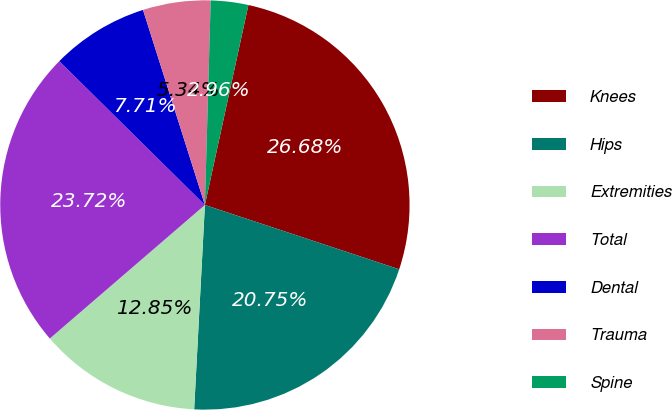<chart> <loc_0><loc_0><loc_500><loc_500><pie_chart><fcel>Knees<fcel>Hips<fcel>Extremities<fcel>Total<fcel>Dental<fcel>Trauma<fcel>Spine<nl><fcel>26.68%<fcel>20.75%<fcel>12.85%<fcel>23.72%<fcel>7.71%<fcel>5.34%<fcel>2.96%<nl></chart> 